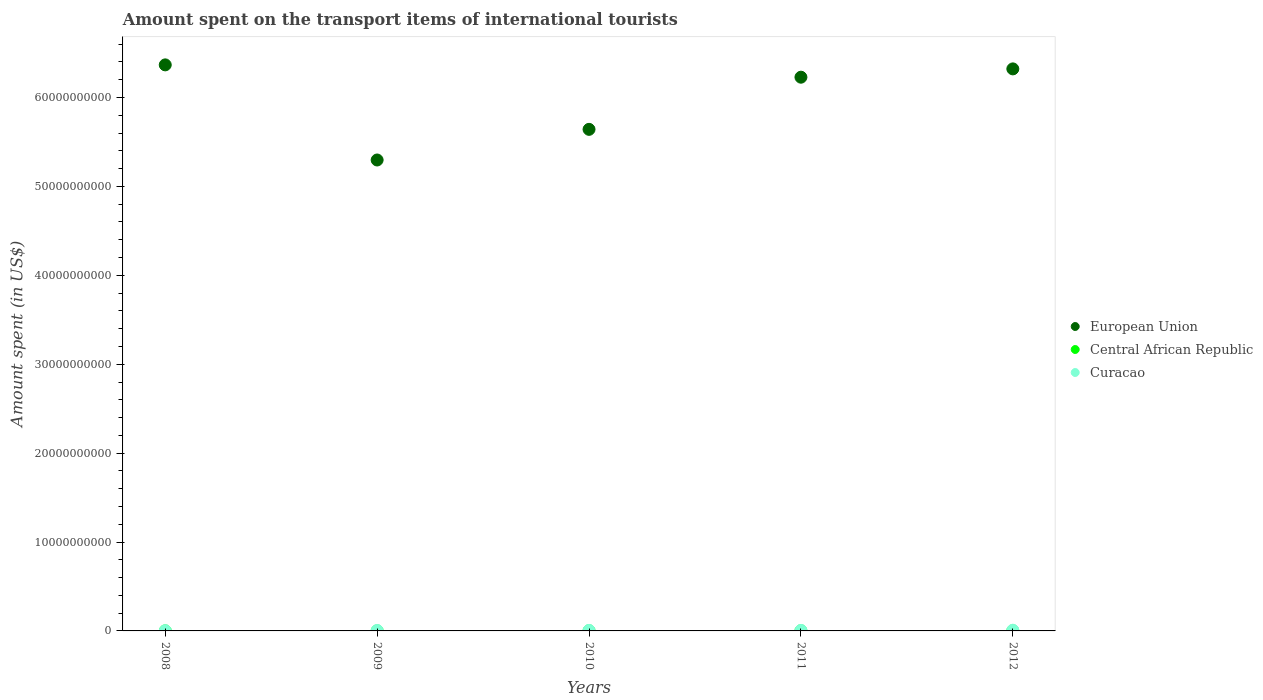How many different coloured dotlines are there?
Provide a succinct answer. 3. Is the number of dotlines equal to the number of legend labels?
Your answer should be very brief. Yes. What is the amount spent on the transport items of international tourists in European Union in 2008?
Give a very brief answer. 6.37e+1. Across all years, what is the maximum amount spent on the transport items of international tourists in Curacao?
Provide a succinct answer. 7.90e+07. Across all years, what is the minimum amount spent on the transport items of international tourists in European Union?
Offer a very short reply. 5.30e+1. In which year was the amount spent on the transport items of international tourists in Curacao maximum?
Provide a short and direct response. 2012. What is the total amount spent on the transport items of international tourists in Central African Republic in the graph?
Give a very brief answer. 7.10e+07. What is the difference between the amount spent on the transport items of international tourists in Central African Republic in 2009 and that in 2012?
Make the answer very short. -1.00e+07. What is the difference between the amount spent on the transport items of international tourists in Central African Republic in 2011 and the amount spent on the transport items of international tourists in Curacao in 2010?
Provide a short and direct response. -3.80e+07. What is the average amount spent on the transport items of international tourists in European Union per year?
Make the answer very short. 5.97e+1. In the year 2008, what is the difference between the amount spent on the transport items of international tourists in European Union and amount spent on the transport items of international tourists in Curacao?
Offer a very short reply. 6.36e+1. What is the ratio of the amount spent on the transport items of international tourists in Curacao in 2009 to that in 2010?
Provide a short and direct response. 0.88. Is the difference between the amount spent on the transport items of international tourists in European Union in 2010 and 2012 greater than the difference between the amount spent on the transport items of international tourists in Curacao in 2010 and 2012?
Offer a very short reply. No. What is the difference between the highest and the second highest amount spent on the transport items of international tourists in Central African Republic?
Your answer should be compact. 1.00e+06. What is the difference between the highest and the lowest amount spent on the transport items of international tourists in Central African Republic?
Make the answer very short. 1.20e+07. In how many years, is the amount spent on the transport items of international tourists in Curacao greater than the average amount spent on the transport items of international tourists in Curacao taken over all years?
Your response must be concise. 3. Is the sum of the amount spent on the transport items of international tourists in European Union in 2008 and 2011 greater than the maximum amount spent on the transport items of international tourists in Central African Republic across all years?
Provide a succinct answer. Yes. Does the amount spent on the transport items of international tourists in Curacao monotonically increase over the years?
Your response must be concise. No. How many dotlines are there?
Offer a terse response. 3. How many years are there in the graph?
Your answer should be compact. 5. What is the difference between two consecutive major ticks on the Y-axis?
Provide a short and direct response. 1.00e+1. Does the graph contain grids?
Your answer should be compact. No. Where does the legend appear in the graph?
Provide a succinct answer. Center right. How many legend labels are there?
Your answer should be compact. 3. How are the legend labels stacked?
Your response must be concise. Vertical. What is the title of the graph?
Keep it short and to the point. Amount spent on the transport items of international tourists. Does "Armenia" appear as one of the legend labels in the graph?
Ensure brevity in your answer.  No. What is the label or title of the Y-axis?
Provide a succinct answer. Amount spent (in US$). What is the Amount spent (in US$) of European Union in 2008?
Your response must be concise. 6.37e+1. What is the Amount spent (in US$) of Curacao in 2008?
Keep it short and to the point. 2.60e+07. What is the Amount spent (in US$) in European Union in 2009?
Make the answer very short. 5.30e+1. What is the Amount spent (in US$) of Central African Republic in 2009?
Offer a very short reply. 9.00e+06. What is the Amount spent (in US$) in Curacao in 2009?
Offer a terse response. 4.90e+07. What is the Amount spent (in US$) of European Union in 2010?
Provide a succinct answer. 5.64e+1. What is the Amount spent (in US$) in Central African Republic in 2010?
Your answer should be compact. 1.80e+07. What is the Amount spent (in US$) of Curacao in 2010?
Offer a very short reply. 5.60e+07. What is the Amount spent (in US$) of European Union in 2011?
Make the answer very short. 6.23e+1. What is the Amount spent (in US$) in Central African Republic in 2011?
Your answer should be compact. 1.80e+07. What is the Amount spent (in US$) of Curacao in 2011?
Your response must be concise. 5.40e+07. What is the Amount spent (in US$) in European Union in 2012?
Offer a very short reply. 6.32e+1. What is the Amount spent (in US$) of Central African Republic in 2012?
Your answer should be very brief. 1.90e+07. What is the Amount spent (in US$) of Curacao in 2012?
Your answer should be compact. 7.90e+07. Across all years, what is the maximum Amount spent (in US$) of European Union?
Keep it short and to the point. 6.37e+1. Across all years, what is the maximum Amount spent (in US$) in Central African Republic?
Offer a terse response. 1.90e+07. Across all years, what is the maximum Amount spent (in US$) of Curacao?
Provide a succinct answer. 7.90e+07. Across all years, what is the minimum Amount spent (in US$) in European Union?
Provide a succinct answer. 5.30e+1. Across all years, what is the minimum Amount spent (in US$) of Central African Republic?
Your answer should be compact. 7.00e+06. Across all years, what is the minimum Amount spent (in US$) of Curacao?
Provide a short and direct response. 2.60e+07. What is the total Amount spent (in US$) in European Union in the graph?
Ensure brevity in your answer.  2.99e+11. What is the total Amount spent (in US$) of Central African Republic in the graph?
Offer a very short reply. 7.10e+07. What is the total Amount spent (in US$) in Curacao in the graph?
Your response must be concise. 2.64e+08. What is the difference between the Amount spent (in US$) in European Union in 2008 and that in 2009?
Keep it short and to the point. 1.07e+1. What is the difference between the Amount spent (in US$) in Curacao in 2008 and that in 2009?
Your answer should be compact. -2.30e+07. What is the difference between the Amount spent (in US$) in European Union in 2008 and that in 2010?
Your answer should be compact. 7.25e+09. What is the difference between the Amount spent (in US$) of Central African Republic in 2008 and that in 2010?
Provide a succinct answer. -1.10e+07. What is the difference between the Amount spent (in US$) in Curacao in 2008 and that in 2010?
Your answer should be compact. -3.00e+07. What is the difference between the Amount spent (in US$) in European Union in 2008 and that in 2011?
Give a very brief answer. 1.39e+09. What is the difference between the Amount spent (in US$) of Central African Republic in 2008 and that in 2011?
Give a very brief answer. -1.10e+07. What is the difference between the Amount spent (in US$) in Curacao in 2008 and that in 2011?
Your answer should be very brief. -2.80e+07. What is the difference between the Amount spent (in US$) in European Union in 2008 and that in 2012?
Offer a terse response. 4.52e+08. What is the difference between the Amount spent (in US$) of Central African Republic in 2008 and that in 2012?
Provide a short and direct response. -1.20e+07. What is the difference between the Amount spent (in US$) of Curacao in 2008 and that in 2012?
Ensure brevity in your answer.  -5.30e+07. What is the difference between the Amount spent (in US$) in European Union in 2009 and that in 2010?
Offer a very short reply. -3.45e+09. What is the difference between the Amount spent (in US$) of Central African Republic in 2009 and that in 2010?
Your answer should be compact. -9.00e+06. What is the difference between the Amount spent (in US$) in Curacao in 2009 and that in 2010?
Make the answer very short. -7.00e+06. What is the difference between the Amount spent (in US$) of European Union in 2009 and that in 2011?
Offer a very short reply. -9.31e+09. What is the difference between the Amount spent (in US$) of Central African Republic in 2009 and that in 2011?
Offer a terse response. -9.00e+06. What is the difference between the Amount spent (in US$) in Curacao in 2009 and that in 2011?
Your answer should be very brief. -5.00e+06. What is the difference between the Amount spent (in US$) of European Union in 2009 and that in 2012?
Your response must be concise. -1.02e+1. What is the difference between the Amount spent (in US$) in Central African Republic in 2009 and that in 2012?
Your answer should be compact. -1.00e+07. What is the difference between the Amount spent (in US$) of Curacao in 2009 and that in 2012?
Ensure brevity in your answer.  -3.00e+07. What is the difference between the Amount spent (in US$) in European Union in 2010 and that in 2011?
Your answer should be very brief. -5.87e+09. What is the difference between the Amount spent (in US$) in Curacao in 2010 and that in 2011?
Provide a short and direct response. 2.00e+06. What is the difference between the Amount spent (in US$) in European Union in 2010 and that in 2012?
Give a very brief answer. -6.80e+09. What is the difference between the Amount spent (in US$) of Curacao in 2010 and that in 2012?
Offer a very short reply. -2.30e+07. What is the difference between the Amount spent (in US$) of European Union in 2011 and that in 2012?
Keep it short and to the point. -9.35e+08. What is the difference between the Amount spent (in US$) in Curacao in 2011 and that in 2012?
Ensure brevity in your answer.  -2.50e+07. What is the difference between the Amount spent (in US$) in European Union in 2008 and the Amount spent (in US$) in Central African Republic in 2009?
Keep it short and to the point. 6.37e+1. What is the difference between the Amount spent (in US$) in European Union in 2008 and the Amount spent (in US$) in Curacao in 2009?
Your answer should be compact. 6.36e+1. What is the difference between the Amount spent (in US$) in Central African Republic in 2008 and the Amount spent (in US$) in Curacao in 2009?
Give a very brief answer. -4.20e+07. What is the difference between the Amount spent (in US$) in European Union in 2008 and the Amount spent (in US$) in Central African Republic in 2010?
Your answer should be compact. 6.37e+1. What is the difference between the Amount spent (in US$) of European Union in 2008 and the Amount spent (in US$) of Curacao in 2010?
Offer a terse response. 6.36e+1. What is the difference between the Amount spent (in US$) of Central African Republic in 2008 and the Amount spent (in US$) of Curacao in 2010?
Keep it short and to the point. -4.90e+07. What is the difference between the Amount spent (in US$) of European Union in 2008 and the Amount spent (in US$) of Central African Republic in 2011?
Offer a very short reply. 6.37e+1. What is the difference between the Amount spent (in US$) of European Union in 2008 and the Amount spent (in US$) of Curacao in 2011?
Offer a terse response. 6.36e+1. What is the difference between the Amount spent (in US$) of Central African Republic in 2008 and the Amount spent (in US$) of Curacao in 2011?
Make the answer very short. -4.70e+07. What is the difference between the Amount spent (in US$) in European Union in 2008 and the Amount spent (in US$) in Central African Republic in 2012?
Offer a very short reply. 6.37e+1. What is the difference between the Amount spent (in US$) in European Union in 2008 and the Amount spent (in US$) in Curacao in 2012?
Provide a short and direct response. 6.36e+1. What is the difference between the Amount spent (in US$) in Central African Republic in 2008 and the Amount spent (in US$) in Curacao in 2012?
Your response must be concise. -7.20e+07. What is the difference between the Amount spent (in US$) of European Union in 2009 and the Amount spent (in US$) of Central African Republic in 2010?
Your answer should be compact. 5.30e+1. What is the difference between the Amount spent (in US$) of European Union in 2009 and the Amount spent (in US$) of Curacao in 2010?
Your answer should be compact. 5.29e+1. What is the difference between the Amount spent (in US$) of Central African Republic in 2009 and the Amount spent (in US$) of Curacao in 2010?
Your answer should be very brief. -4.70e+07. What is the difference between the Amount spent (in US$) in European Union in 2009 and the Amount spent (in US$) in Central African Republic in 2011?
Offer a very short reply. 5.30e+1. What is the difference between the Amount spent (in US$) in European Union in 2009 and the Amount spent (in US$) in Curacao in 2011?
Provide a short and direct response. 5.29e+1. What is the difference between the Amount spent (in US$) in Central African Republic in 2009 and the Amount spent (in US$) in Curacao in 2011?
Your answer should be very brief. -4.50e+07. What is the difference between the Amount spent (in US$) in European Union in 2009 and the Amount spent (in US$) in Central African Republic in 2012?
Offer a very short reply. 5.30e+1. What is the difference between the Amount spent (in US$) in European Union in 2009 and the Amount spent (in US$) in Curacao in 2012?
Offer a very short reply. 5.29e+1. What is the difference between the Amount spent (in US$) in Central African Republic in 2009 and the Amount spent (in US$) in Curacao in 2012?
Give a very brief answer. -7.00e+07. What is the difference between the Amount spent (in US$) of European Union in 2010 and the Amount spent (in US$) of Central African Republic in 2011?
Ensure brevity in your answer.  5.64e+1. What is the difference between the Amount spent (in US$) of European Union in 2010 and the Amount spent (in US$) of Curacao in 2011?
Your response must be concise. 5.64e+1. What is the difference between the Amount spent (in US$) in Central African Republic in 2010 and the Amount spent (in US$) in Curacao in 2011?
Offer a terse response. -3.60e+07. What is the difference between the Amount spent (in US$) in European Union in 2010 and the Amount spent (in US$) in Central African Republic in 2012?
Offer a terse response. 5.64e+1. What is the difference between the Amount spent (in US$) in European Union in 2010 and the Amount spent (in US$) in Curacao in 2012?
Keep it short and to the point. 5.63e+1. What is the difference between the Amount spent (in US$) of Central African Republic in 2010 and the Amount spent (in US$) of Curacao in 2012?
Make the answer very short. -6.10e+07. What is the difference between the Amount spent (in US$) of European Union in 2011 and the Amount spent (in US$) of Central African Republic in 2012?
Make the answer very short. 6.23e+1. What is the difference between the Amount spent (in US$) in European Union in 2011 and the Amount spent (in US$) in Curacao in 2012?
Your answer should be compact. 6.22e+1. What is the difference between the Amount spent (in US$) in Central African Republic in 2011 and the Amount spent (in US$) in Curacao in 2012?
Offer a very short reply. -6.10e+07. What is the average Amount spent (in US$) in European Union per year?
Make the answer very short. 5.97e+1. What is the average Amount spent (in US$) in Central African Republic per year?
Your answer should be very brief. 1.42e+07. What is the average Amount spent (in US$) of Curacao per year?
Provide a short and direct response. 5.28e+07. In the year 2008, what is the difference between the Amount spent (in US$) in European Union and Amount spent (in US$) in Central African Republic?
Your response must be concise. 6.37e+1. In the year 2008, what is the difference between the Amount spent (in US$) of European Union and Amount spent (in US$) of Curacao?
Your response must be concise. 6.36e+1. In the year 2008, what is the difference between the Amount spent (in US$) in Central African Republic and Amount spent (in US$) in Curacao?
Your answer should be compact. -1.90e+07. In the year 2009, what is the difference between the Amount spent (in US$) in European Union and Amount spent (in US$) in Central African Republic?
Offer a very short reply. 5.30e+1. In the year 2009, what is the difference between the Amount spent (in US$) of European Union and Amount spent (in US$) of Curacao?
Provide a short and direct response. 5.29e+1. In the year 2009, what is the difference between the Amount spent (in US$) in Central African Republic and Amount spent (in US$) in Curacao?
Ensure brevity in your answer.  -4.00e+07. In the year 2010, what is the difference between the Amount spent (in US$) in European Union and Amount spent (in US$) in Central African Republic?
Ensure brevity in your answer.  5.64e+1. In the year 2010, what is the difference between the Amount spent (in US$) in European Union and Amount spent (in US$) in Curacao?
Your answer should be very brief. 5.64e+1. In the year 2010, what is the difference between the Amount spent (in US$) in Central African Republic and Amount spent (in US$) in Curacao?
Your response must be concise. -3.80e+07. In the year 2011, what is the difference between the Amount spent (in US$) in European Union and Amount spent (in US$) in Central African Republic?
Provide a succinct answer. 6.23e+1. In the year 2011, what is the difference between the Amount spent (in US$) of European Union and Amount spent (in US$) of Curacao?
Your response must be concise. 6.22e+1. In the year 2011, what is the difference between the Amount spent (in US$) in Central African Republic and Amount spent (in US$) in Curacao?
Offer a very short reply. -3.60e+07. In the year 2012, what is the difference between the Amount spent (in US$) in European Union and Amount spent (in US$) in Central African Republic?
Make the answer very short. 6.32e+1. In the year 2012, what is the difference between the Amount spent (in US$) of European Union and Amount spent (in US$) of Curacao?
Your answer should be compact. 6.31e+1. In the year 2012, what is the difference between the Amount spent (in US$) in Central African Republic and Amount spent (in US$) in Curacao?
Ensure brevity in your answer.  -6.00e+07. What is the ratio of the Amount spent (in US$) in European Union in 2008 to that in 2009?
Your answer should be compact. 1.2. What is the ratio of the Amount spent (in US$) of Curacao in 2008 to that in 2009?
Provide a short and direct response. 0.53. What is the ratio of the Amount spent (in US$) of European Union in 2008 to that in 2010?
Give a very brief answer. 1.13. What is the ratio of the Amount spent (in US$) in Central African Republic in 2008 to that in 2010?
Keep it short and to the point. 0.39. What is the ratio of the Amount spent (in US$) of Curacao in 2008 to that in 2010?
Keep it short and to the point. 0.46. What is the ratio of the Amount spent (in US$) in European Union in 2008 to that in 2011?
Ensure brevity in your answer.  1.02. What is the ratio of the Amount spent (in US$) in Central African Republic in 2008 to that in 2011?
Make the answer very short. 0.39. What is the ratio of the Amount spent (in US$) in Curacao in 2008 to that in 2011?
Give a very brief answer. 0.48. What is the ratio of the Amount spent (in US$) in European Union in 2008 to that in 2012?
Make the answer very short. 1.01. What is the ratio of the Amount spent (in US$) of Central African Republic in 2008 to that in 2012?
Offer a terse response. 0.37. What is the ratio of the Amount spent (in US$) of Curacao in 2008 to that in 2012?
Give a very brief answer. 0.33. What is the ratio of the Amount spent (in US$) of European Union in 2009 to that in 2010?
Provide a succinct answer. 0.94. What is the ratio of the Amount spent (in US$) of Curacao in 2009 to that in 2010?
Make the answer very short. 0.88. What is the ratio of the Amount spent (in US$) of European Union in 2009 to that in 2011?
Offer a terse response. 0.85. What is the ratio of the Amount spent (in US$) of Central African Republic in 2009 to that in 2011?
Offer a very short reply. 0.5. What is the ratio of the Amount spent (in US$) in Curacao in 2009 to that in 2011?
Provide a succinct answer. 0.91. What is the ratio of the Amount spent (in US$) in European Union in 2009 to that in 2012?
Offer a very short reply. 0.84. What is the ratio of the Amount spent (in US$) in Central African Republic in 2009 to that in 2012?
Provide a short and direct response. 0.47. What is the ratio of the Amount spent (in US$) in Curacao in 2009 to that in 2012?
Offer a terse response. 0.62. What is the ratio of the Amount spent (in US$) in European Union in 2010 to that in 2011?
Offer a very short reply. 0.91. What is the ratio of the Amount spent (in US$) of Curacao in 2010 to that in 2011?
Ensure brevity in your answer.  1.04. What is the ratio of the Amount spent (in US$) of European Union in 2010 to that in 2012?
Offer a terse response. 0.89. What is the ratio of the Amount spent (in US$) of Central African Republic in 2010 to that in 2012?
Give a very brief answer. 0.95. What is the ratio of the Amount spent (in US$) in Curacao in 2010 to that in 2012?
Make the answer very short. 0.71. What is the ratio of the Amount spent (in US$) of European Union in 2011 to that in 2012?
Keep it short and to the point. 0.99. What is the ratio of the Amount spent (in US$) in Curacao in 2011 to that in 2012?
Ensure brevity in your answer.  0.68. What is the difference between the highest and the second highest Amount spent (in US$) in European Union?
Make the answer very short. 4.52e+08. What is the difference between the highest and the second highest Amount spent (in US$) in Central African Republic?
Your response must be concise. 1.00e+06. What is the difference between the highest and the second highest Amount spent (in US$) of Curacao?
Keep it short and to the point. 2.30e+07. What is the difference between the highest and the lowest Amount spent (in US$) of European Union?
Provide a succinct answer. 1.07e+1. What is the difference between the highest and the lowest Amount spent (in US$) in Central African Republic?
Ensure brevity in your answer.  1.20e+07. What is the difference between the highest and the lowest Amount spent (in US$) in Curacao?
Provide a succinct answer. 5.30e+07. 